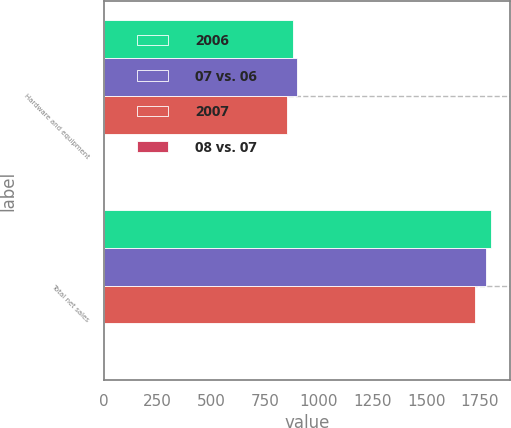<chart> <loc_0><loc_0><loc_500><loc_500><stacked_bar_chart><ecel><fcel>Hardware and equipment<fcel>Total net sales<nl><fcel>2006<fcel>879<fcel>1799<nl><fcel>07 vs. 06<fcel>899<fcel>1779<nl><fcel>2007<fcel>852<fcel>1729<nl><fcel>08 vs. 07<fcel>2<fcel>1<nl></chart> 